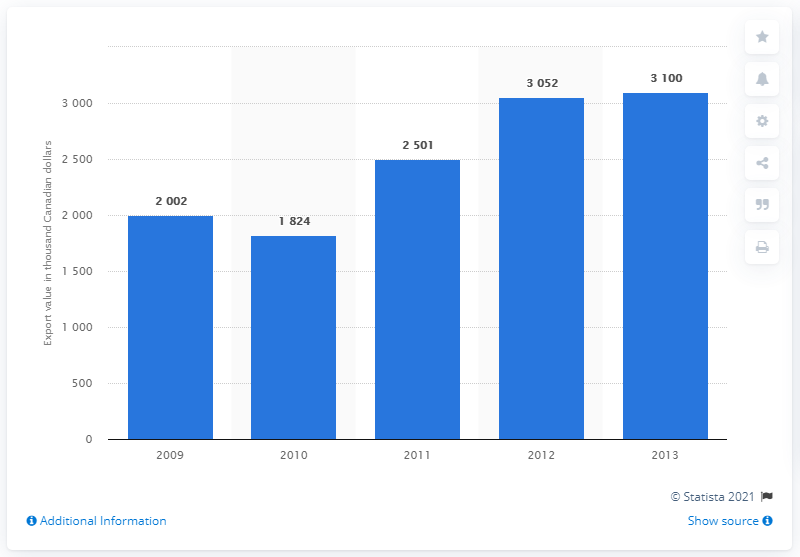List a handful of essential elements in this visual. The value of maple sugar and maple syrup export from France increased in the year 2009. 